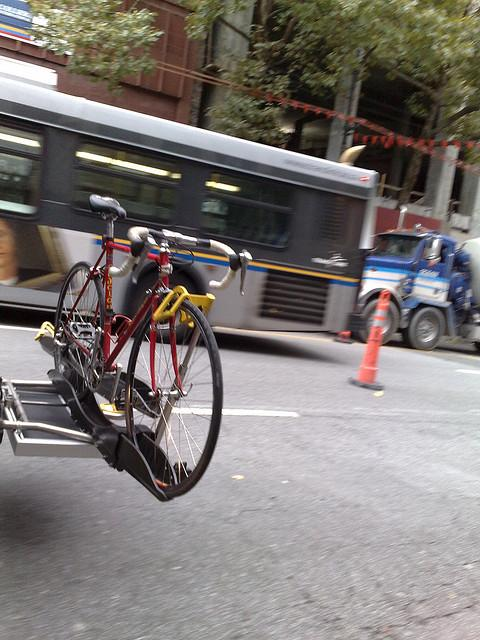What is to the left of the cone? bus 